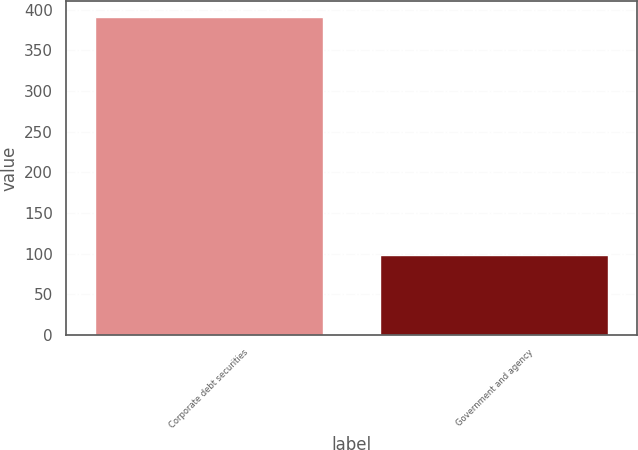Convert chart to OTSL. <chart><loc_0><loc_0><loc_500><loc_500><bar_chart><fcel>Corporate debt securities<fcel>Government and agency<nl><fcel>391<fcel>98<nl></chart> 